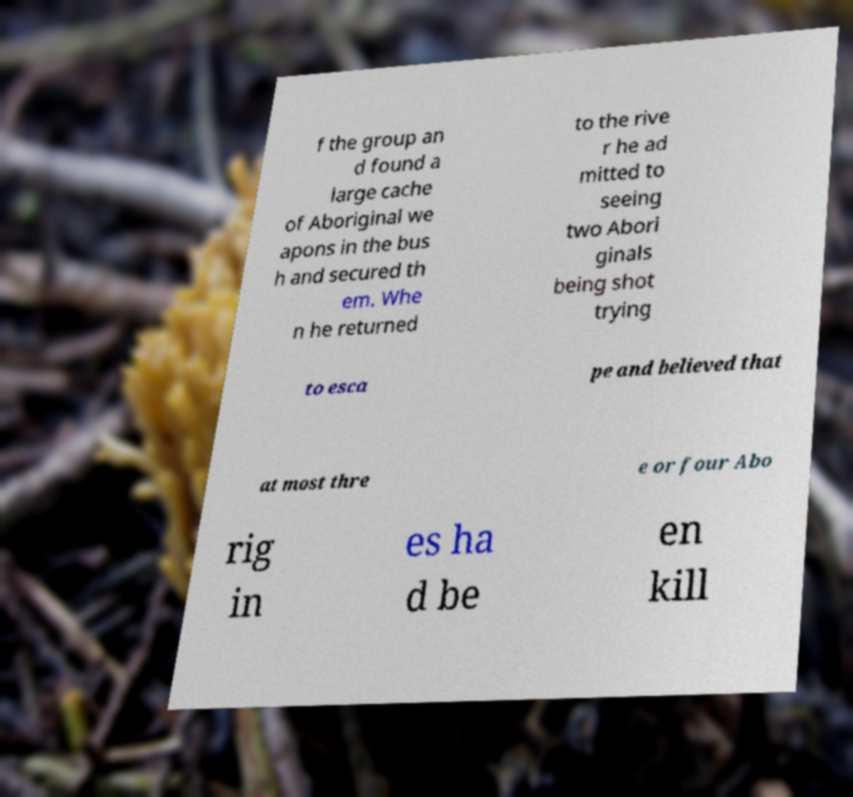Can you accurately transcribe the text from the provided image for me? f the group an d found a large cache of Aboriginal we apons in the bus h and secured th em. Whe n he returned to the rive r he ad mitted to seeing two Abori ginals being shot trying to esca pe and believed that at most thre e or four Abo rig in es ha d be en kill 